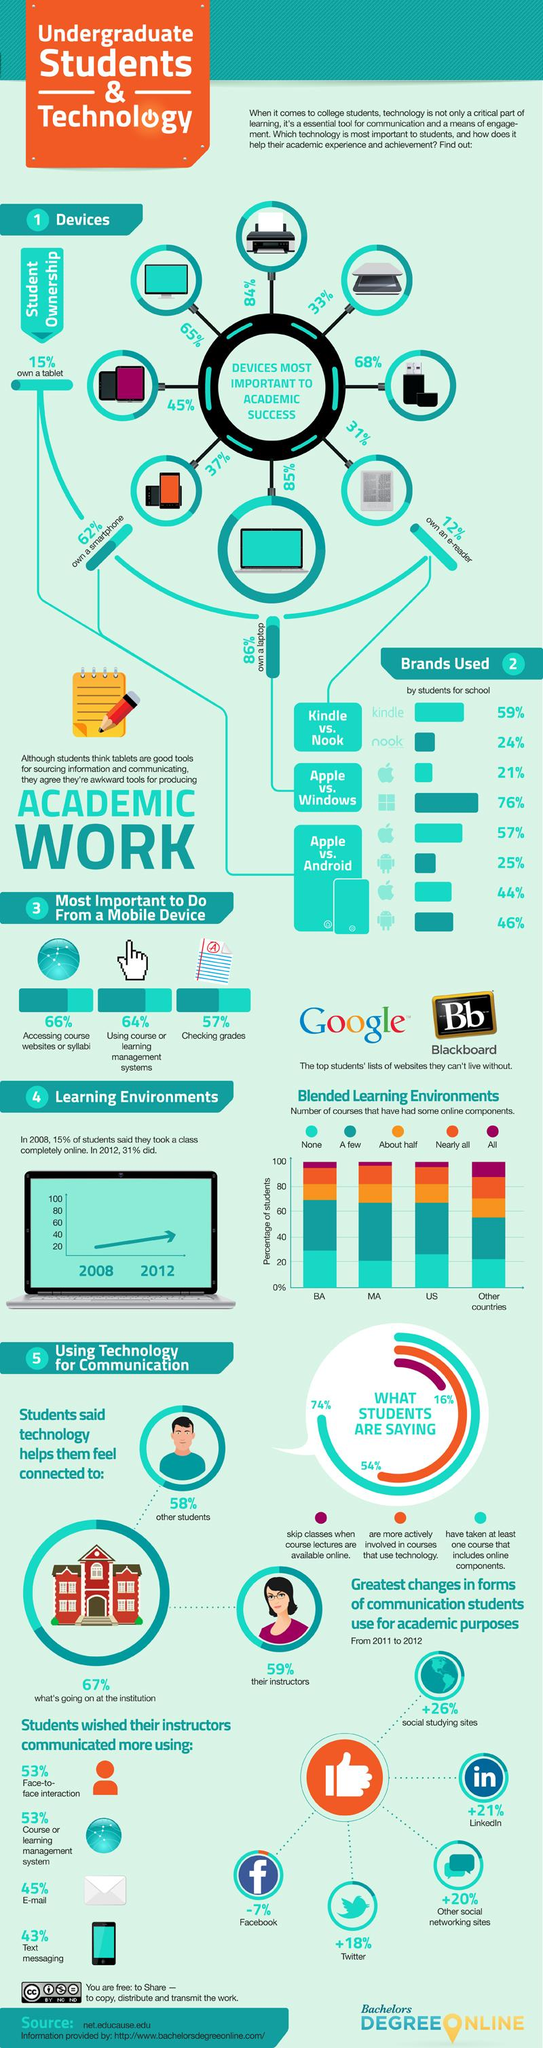Specify some key components in this picture. A significant percentage of students, approximately 16%, skip classes when course lectures are available online. A higher number of students use laptops instead of tablets. Seventy-four percent of the participants have taken at least one course with online components. Approximately 44% of smartphone users use Apple phones. According to a recent survey, 46% of smartphone users use Android phones. 